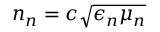Convert formula to latex. <formula><loc_0><loc_0><loc_500><loc_500>n _ { n } = c \sqrt { \epsilon _ { n } \mu _ { n } }</formula> 